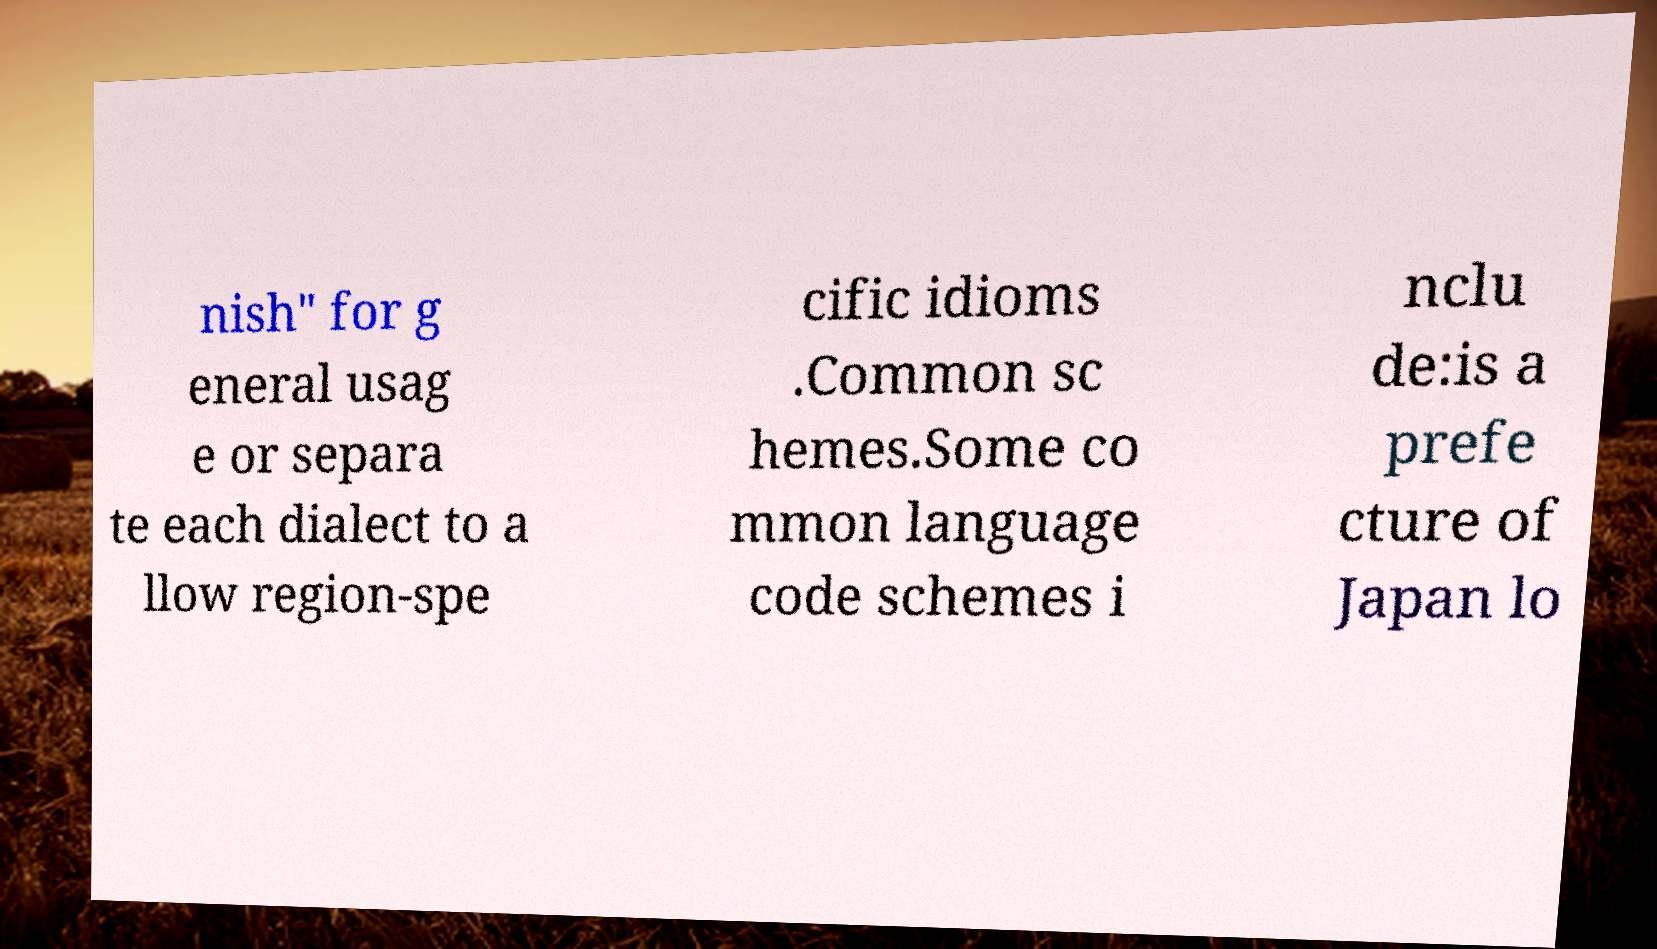I need the written content from this picture converted into text. Can you do that? nish" for g eneral usag e or separa te each dialect to a llow region-spe cific idioms .Common sc hemes.Some co mmon language code schemes i nclu de:is a prefe cture of Japan lo 